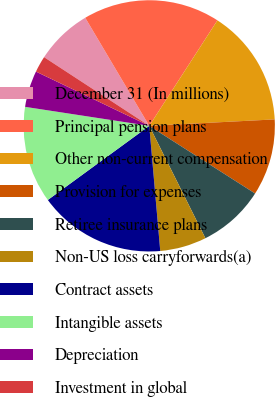Convert chart. <chart><loc_0><loc_0><loc_500><loc_500><pie_chart><fcel>December 31 (In millions)<fcel>Principal pension plans<fcel>Other non-current compensation<fcel>Provision for expenses<fcel>Retiree insurance plans<fcel>Non-US loss carryforwards(a)<fcel>Contract assets<fcel>Intangible assets<fcel>Depreciation<fcel>Investment in global<nl><fcel>7.28%<fcel>17.64%<fcel>15.05%<fcel>9.87%<fcel>8.57%<fcel>5.98%<fcel>16.35%<fcel>12.46%<fcel>4.69%<fcel>2.1%<nl></chart> 